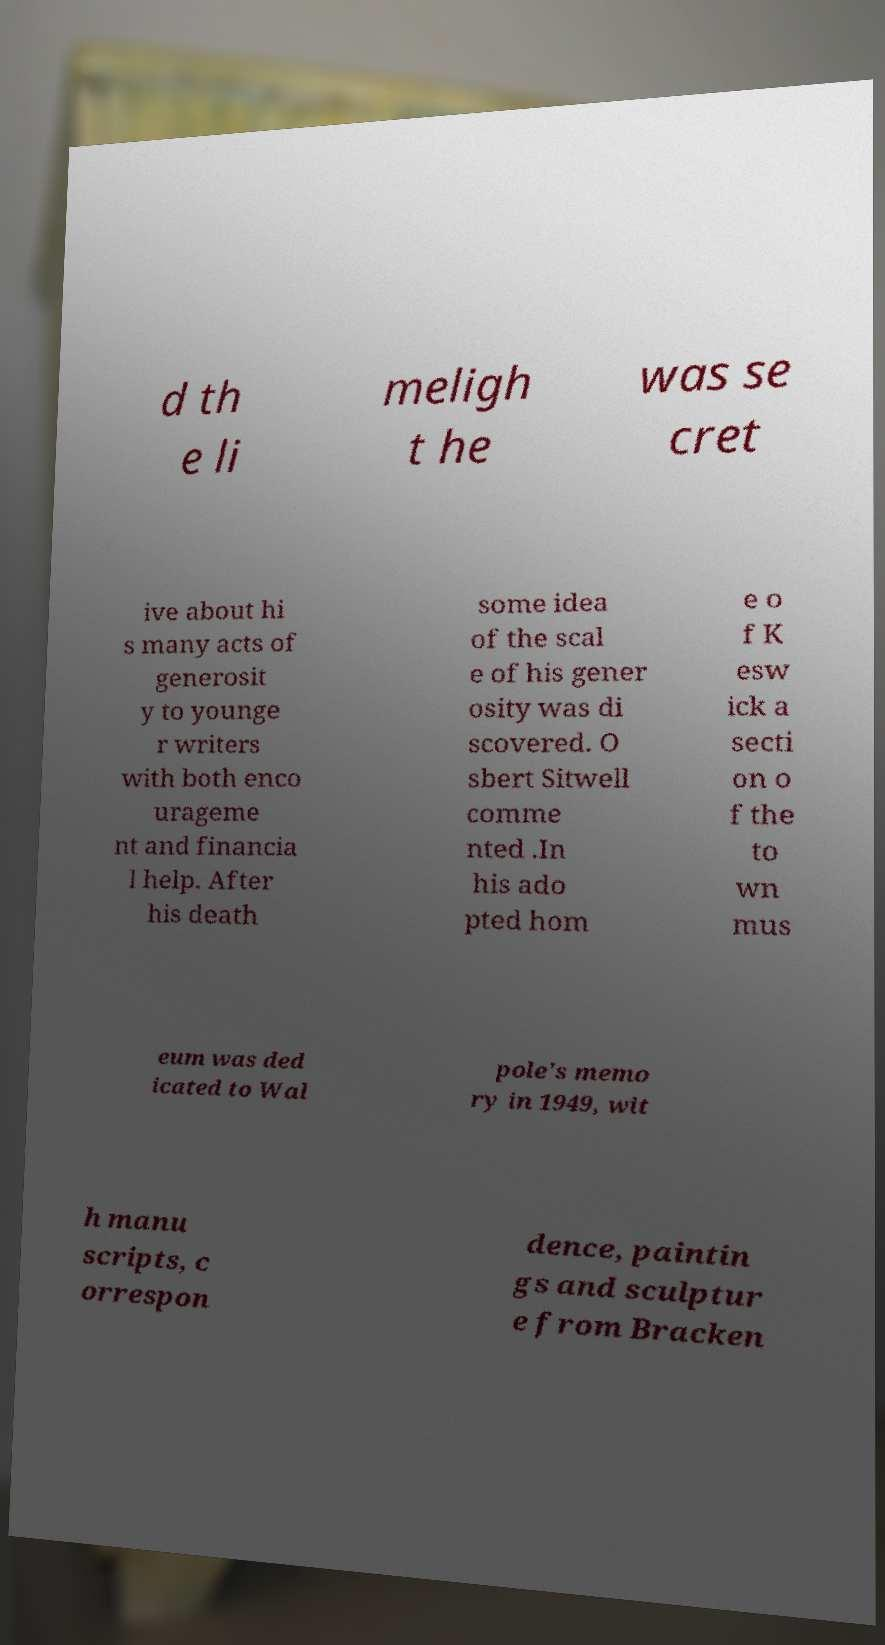There's text embedded in this image that I need extracted. Can you transcribe it verbatim? d th e li meligh t he was se cret ive about hi s many acts of generosit y to younge r writers with both enco urageme nt and financia l help. After his death some idea of the scal e of his gener osity was di scovered. O sbert Sitwell comme nted .In his ado pted hom e o f K esw ick a secti on o f the to wn mus eum was ded icated to Wal pole's memo ry in 1949, wit h manu scripts, c orrespon dence, paintin gs and sculptur e from Bracken 